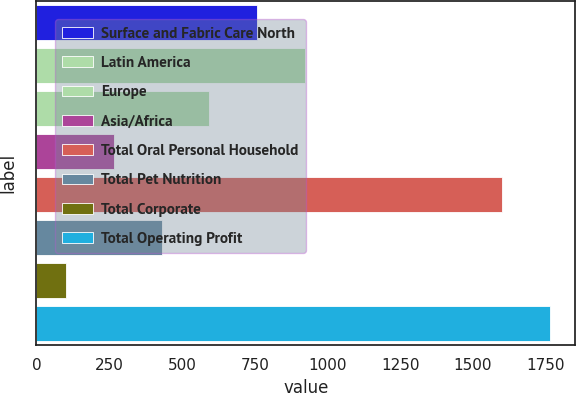Convert chart to OTSL. <chart><loc_0><loc_0><loc_500><loc_500><bar_chart><fcel>Surface and Fabric Care North<fcel>Latin America<fcel>Europe<fcel>Asia/Africa<fcel>Total Oral Personal Household<fcel>Total Pet Nutrition<fcel>Total Corporate<fcel>Total Operating Profit<nl><fcel>757.7<fcel>921.5<fcel>593.9<fcel>266.3<fcel>1599.5<fcel>430.1<fcel>102.5<fcel>1763.3<nl></chart> 